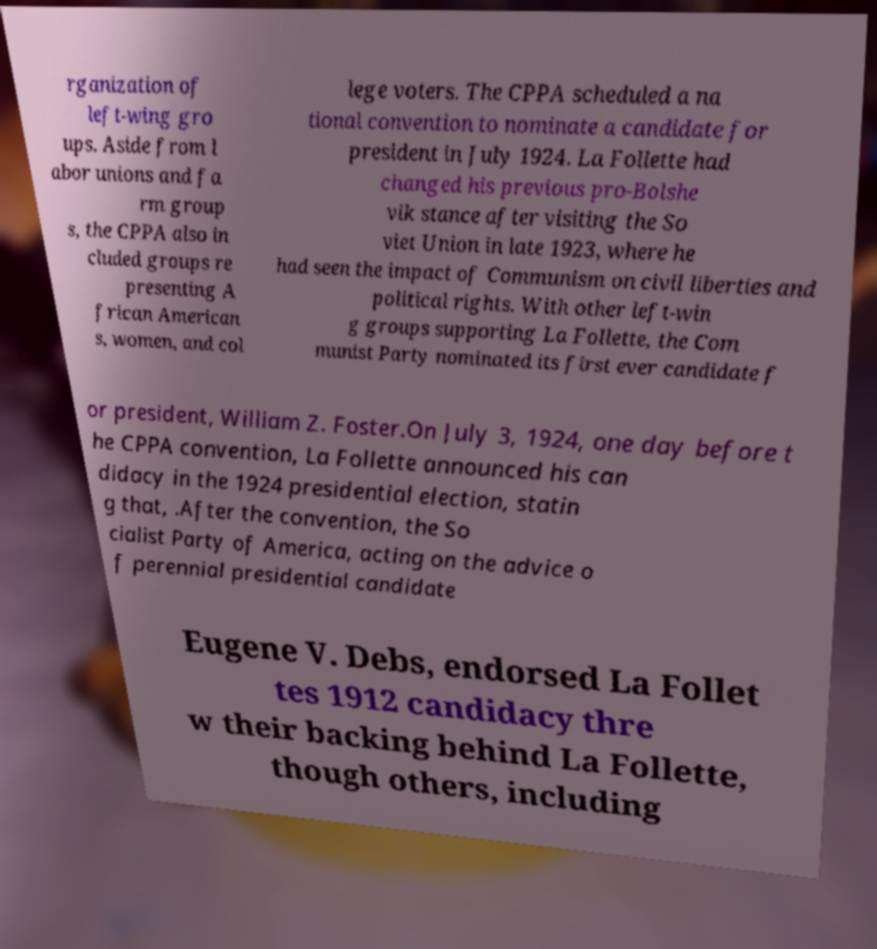For documentation purposes, I need the text within this image transcribed. Could you provide that? rganization of left-wing gro ups. Aside from l abor unions and fa rm group s, the CPPA also in cluded groups re presenting A frican American s, women, and col lege voters. The CPPA scheduled a na tional convention to nominate a candidate for president in July 1924. La Follette had changed his previous pro-Bolshe vik stance after visiting the So viet Union in late 1923, where he had seen the impact of Communism on civil liberties and political rights. With other left-win g groups supporting La Follette, the Com munist Party nominated its first ever candidate f or president, William Z. Foster.On July 3, 1924, one day before t he CPPA convention, La Follette announced his can didacy in the 1924 presidential election, statin g that, .After the convention, the So cialist Party of America, acting on the advice o f perennial presidential candidate Eugene V. Debs, endorsed La Follet tes 1912 candidacy thre w their backing behind La Follette, though others, including 